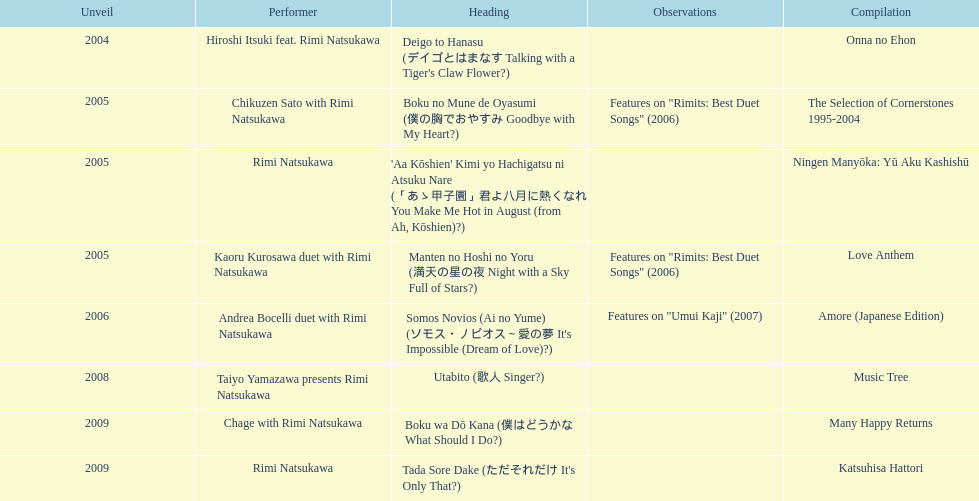How many other appearance did this artist make in 2005? 3. 